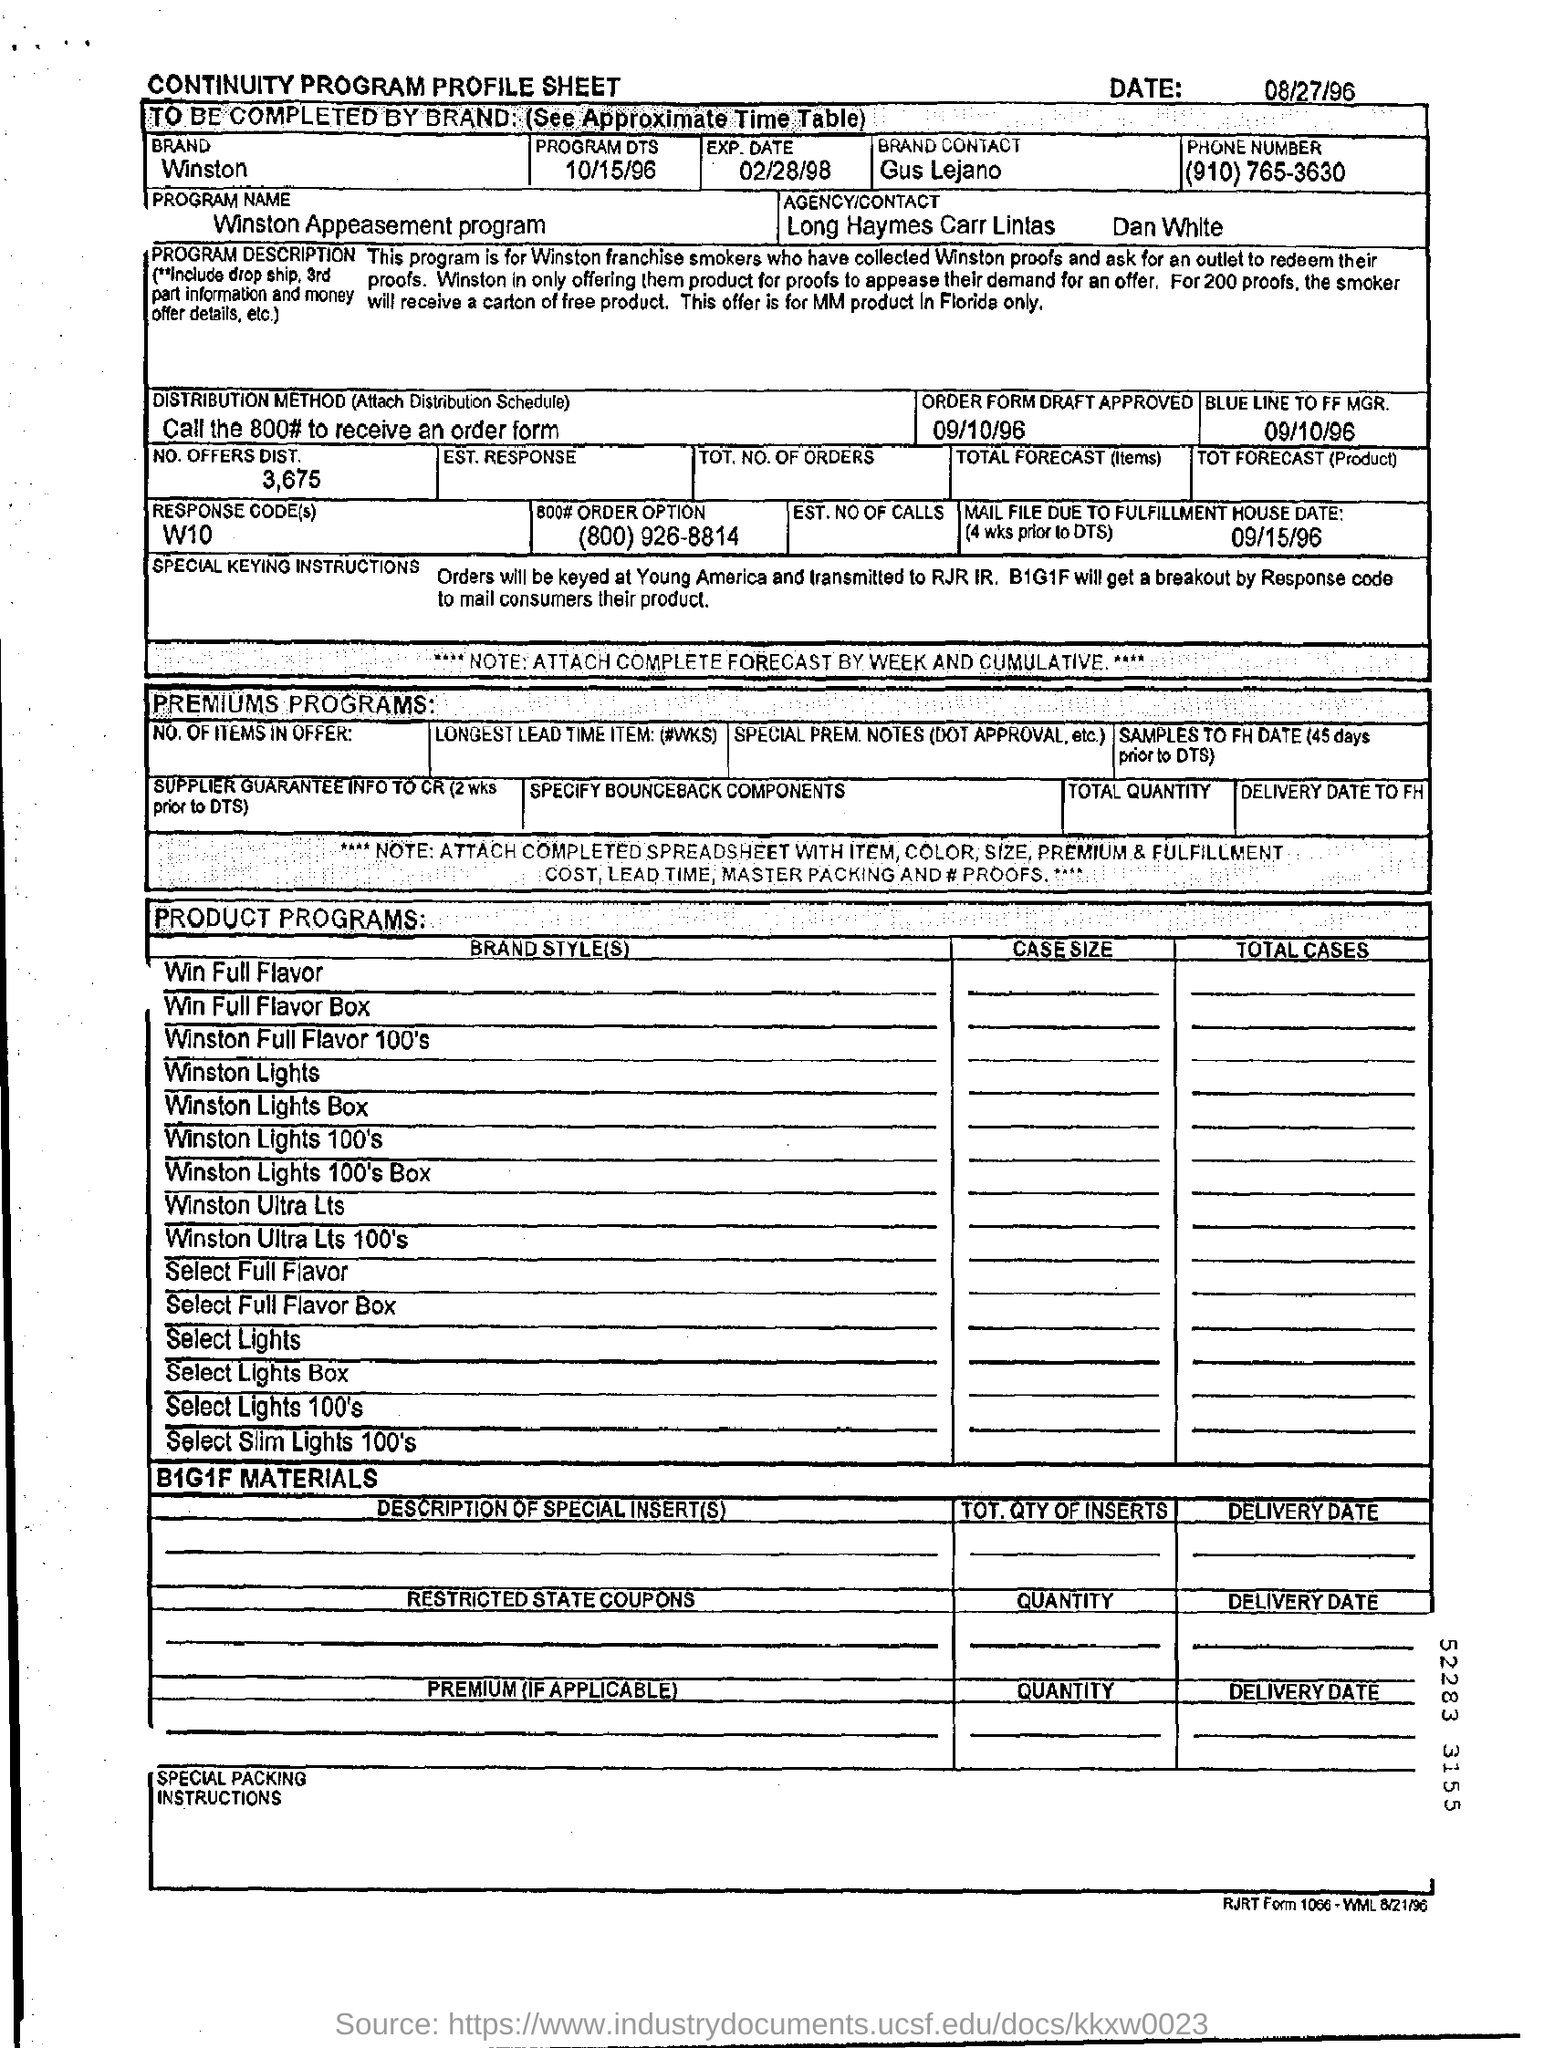List a handful of essential elements in this visual. The distribution method involves calling the 800 number to obtain an order form. Winston, the brand mentioned in the form, is... The name of the agency is Long Haymes Carr Lintas. The form is dated August 27, 1996. The brand contact is Gus Lejano. 